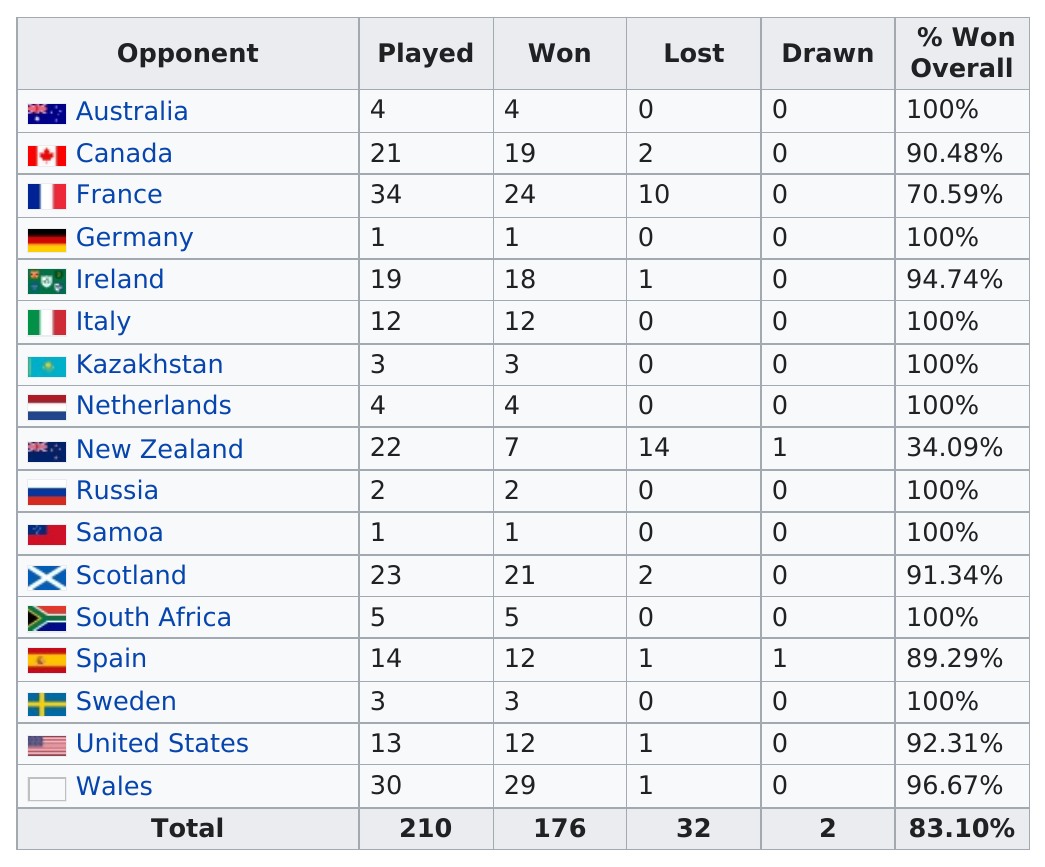Give some essential details in this illustration. How many teams' win percentages were below 90% in total? Out of the teams with 100% wins, the team that played the most games was 12... Scotland lost more games than Wales. Wales won more games than Scotland. It is more likely that they had a better record against Canada than against Scotland, as the sentence states that they had a better record against Canada. The England Women's Rugby Football Union has played more than thirty games against two countries: France and Wales. 